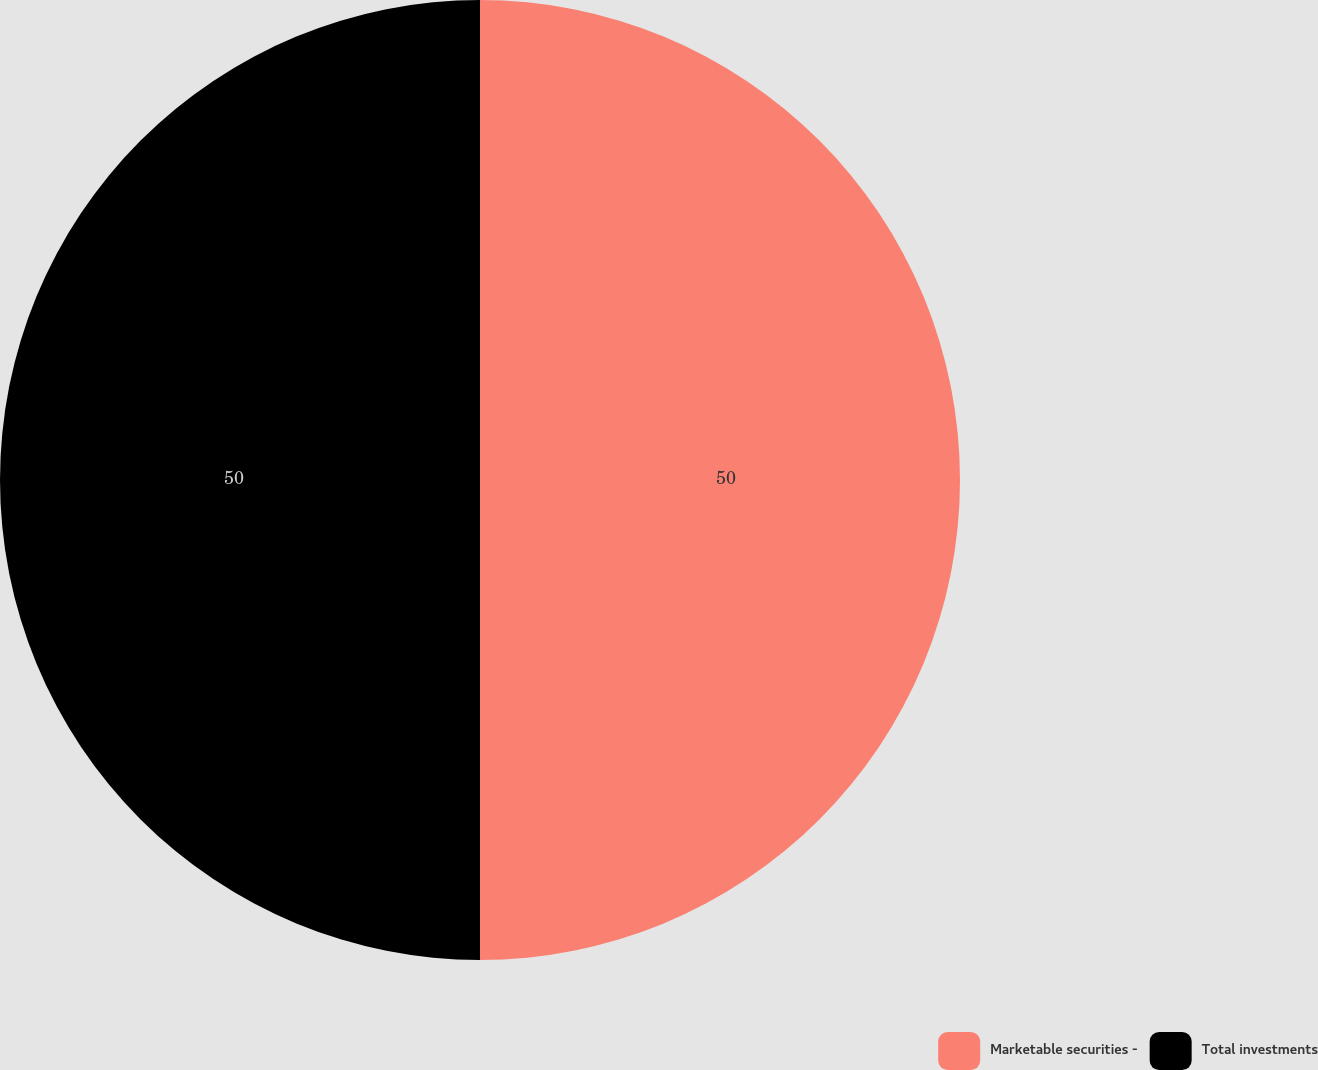<chart> <loc_0><loc_0><loc_500><loc_500><pie_chart><fcel>Marketable securities -<fcel>Total investments<nl><fcel>50.0%<fcel>50.0%<nl></chart> 